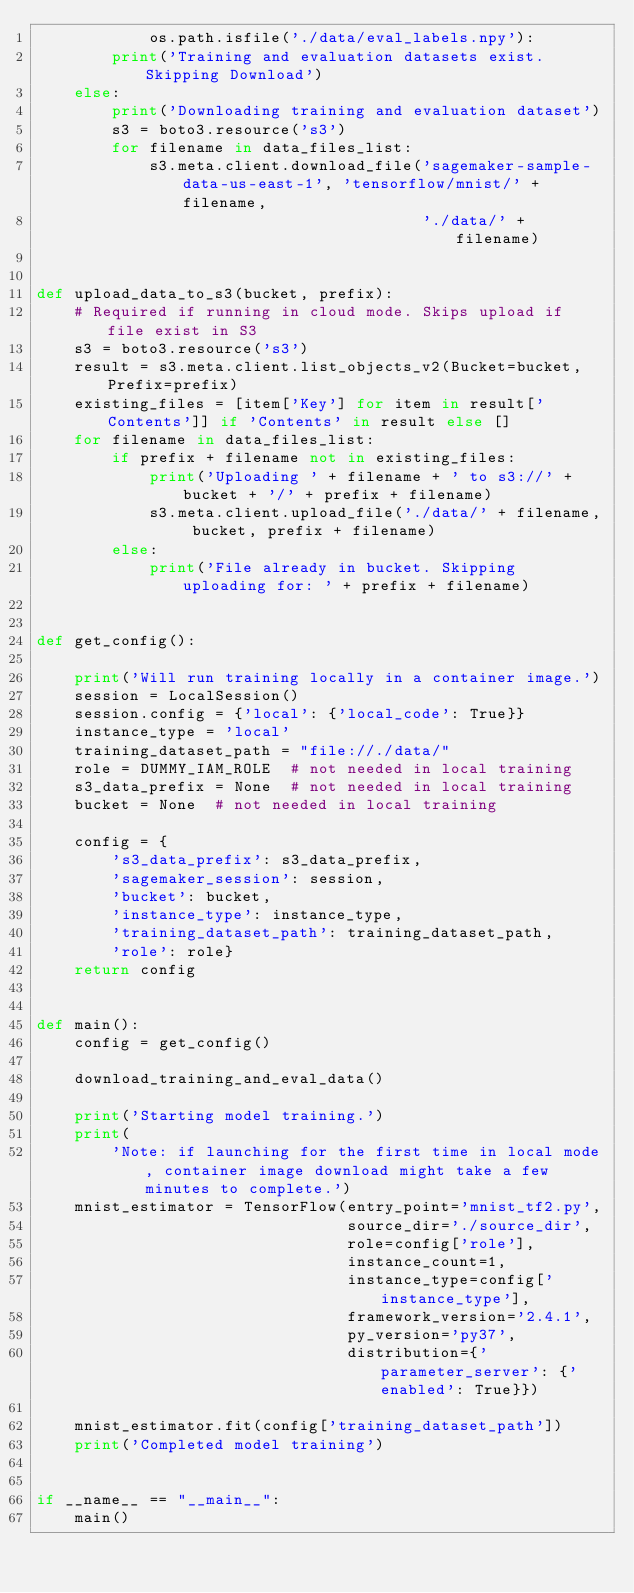Convert code to text. <code><loc_0><loc_0><loc_500><loc_500><_Python_>            os.path.isfile('./data/eval_labels.npy'):
        print('Training and evaluation datasets exist. Skipping Download')
    else:
        print('Downloading training and evaluation dataset')
        s3 = boto3.resource('s3')
        for filename in data_files_list:
            s3.meta.client.download_file('sagemaker-sample-data-us-east-1', 'tensorflow/mnist/' + filename,
                                         './data/' + filename)


def upload_data_to_s3(bucket, prefix):
    # Required if running in cloud mode. Skips upload if file exist in S3
    s3 = boto3.resource('s3')
    result = s3.meta.client.list_objects_v2(Bucket=bucket, Prefix=prefix)
    existing_files = [item['Key'] for item in result['Contents']] if 'Contents' in result else []
    for filename in data_files_list:
        if prefix + filename not in existing_files:
            print('Uploading ' + filename + ' to s3://' + bucket + '/' + prefix + filename)
            s3.meta.client.upload_file('./data/' + filename, bucket, prefix + filename)
        else:
            print('File already in bucket. Skipping uploading for: ' + prefix + filename)


def get_config():

    print('Will run training locally in a container image.')
    session = LocalSession()
    session.config = {'local': {'local_code': True}}
    instance_type = 'local'
    training_dataset_path = "file://./data/"
    role = DUMMY_IAM_ROLE  # not needed in local training
    s3_data_prefix = None  # not needed in local training
    bucket = None  # not needed in local training

    config = {
        's3_data_prefix': s3_data_prefix,
        'sagemaker_session': session,
        'bucket': bucket,
        'instance_type': instance_type,
        'training_dataset_path': training_dataset_path,
        'role': role}
    return config


def main():
    config = get_config()

    download_training_and_eval_data()

    print('Starting model training.')
    print(
        'Note: if launching for the first time in local mode, container image download might take a few minutes to complete.')
    mnist_estimator = TensorFlow(entry_point='mnist_tf2.py',
                                 source_dir='./source_dir',
                                 role=config['role'],
                                 instance_count=1,
                                 instance_type=config['instance_type'],
                                 framework_version='2.4.1',
                                 py_version='py37',
                                 distribution={'parameter_server': {'enabled': True}})

    mnist_estimator.fit(config['training_dataset_path'])
    print('Completed model training')


if __name__ == "__main__":
    main()
</code> 